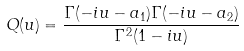<formula> <loc_0><loc_0><loc_500><loc_500>Q ( u ) = \frac { \Gamma ( - i u - a _ { 1 } ) \Gamma ( - i u - a _ { 2 } ) } { \Gamma ^ { 2 } ( 1 - i u ) }</formula> 